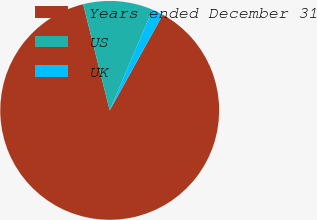<chart> <loc_0><loc_0><loc_500><loc_500><pie_chart><fcel>Years ended December 31<fcel>US<fcel>UK<nl><fcel>88.03%<fcel>10.3%<fcel>1.67%<nl></chart> 